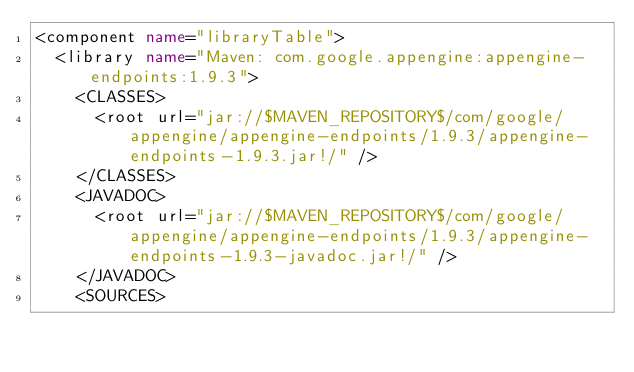<code> <loc_0><loc_0><loc_500><loc_500><_XML_><component name="libraryTable">
  <library name="Maven: com.google.appengine:appengine-endpoints:1.9.3">
    <CLASSES>
      <root url="jar://$MAVEN_REPOSITORY$/com/google/appengine/appengine-endpoints/1.9.3/appengine-endpoints-1.9.3.jar!/" />
    </CLASSES>
    <JAVADOC>
      <root url="jar://$MAVEN_REPOSITORY$/com/google/appengine/appengine-endpoints/1.9.3/appengine-endpoints-1.9.3-javadoc.jar!/" />
    </JAVADOC>
    <SOURCES></code> 